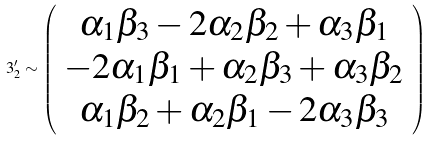<formula> <loc_0><loc_0><loc_500><loc_500>3 ^ { \prime } _ { 2 } \sim \left ( \begin{array} { c } \alpha _ { 1 } \beta _ { 3 } - 2 \alpha _ { 2 } \beta _ { 2 } + \alpha _ { 3 } \beta _ { 1 } \\ - 2 \alpha _ { 1 } \beta _ { 1 } + \alpha _ { 2 } \beta _ { 3 } + \alpha _ { 3 } \beta _ { 2 } \\ \alpha _ { 1 } \beta _ { 2 } + \alpha _ { 2 } \beta _ { 1 } - 2 \alpha _ { 3 } \beta _ { 3 } \end{array} \right )</formula> 